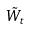Convert formula to latex. <formula><loc_0><loc_0><loc_500><loc_500>\tilde { W } _ { t }</formula> 